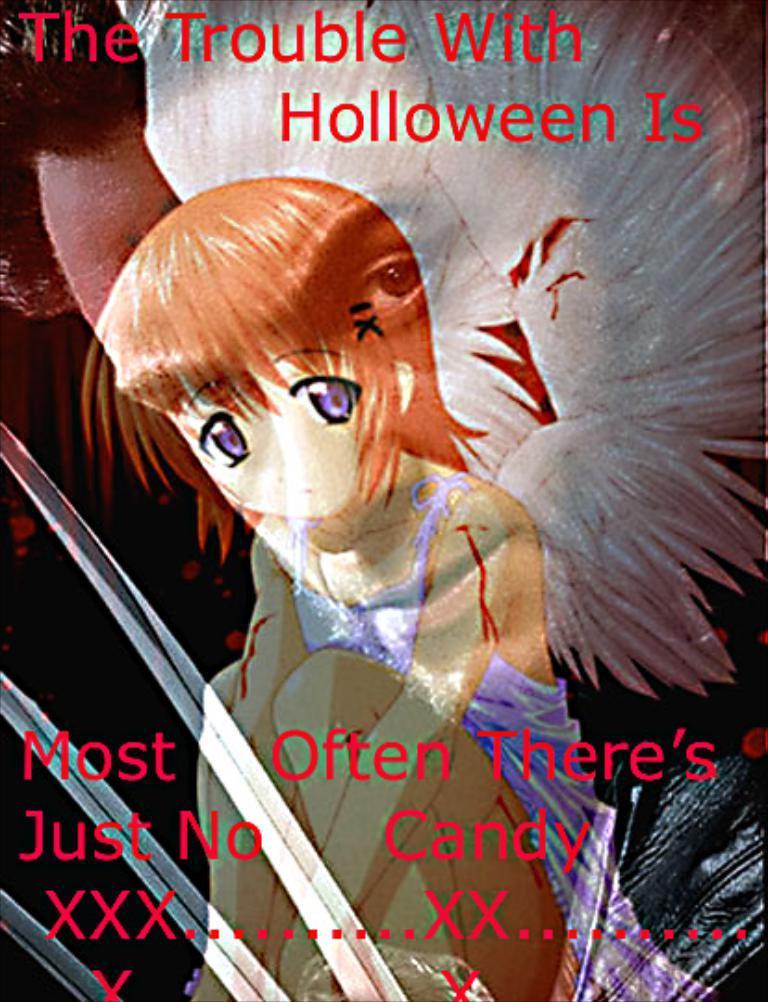Could you give a brief overview of what you see in this image? There is an animated image and some quotation is mentioned on that image. 